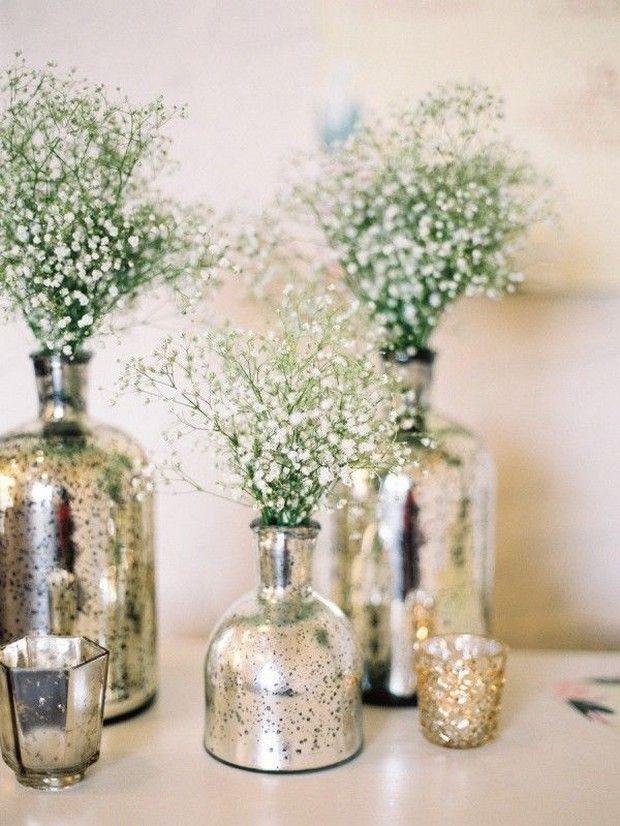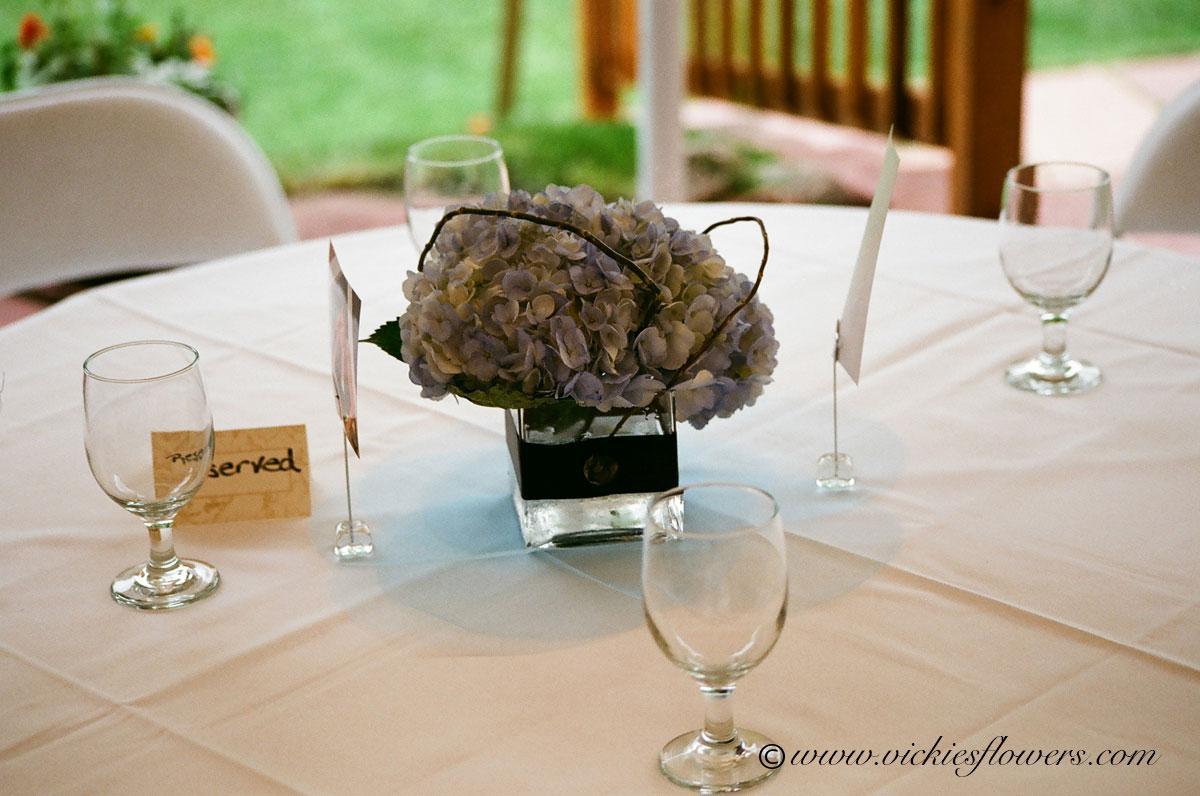The first image is the image on the left, the second image is the image on the right. Given the left and right images, does the statement "Two clear vases with green fruit in their water-filled bases are shown in the right image." hold true? Answer yes or no. No. The first image is the image on the left, the second image is the image on the right. For the images shown, is this caption "The vases in the left image are silver colored." true? Answer yes or no. Yes. 